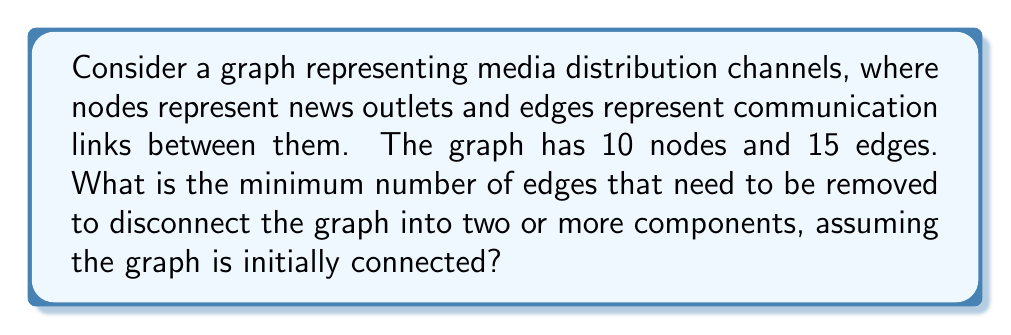Could you help me with this problem? To solve this problem, we need to understand the concept of edge connectivity in graph theory.

1. Edge connectivity is defined as the minimum number of edges that need to be removed to disconnect a graph.

2. For a connected graph with $n$ nodes, the edge connectivity is always less than or equal to the minimum degree of any node in the graph.

3. In this case, we have 10 nodes and 15 edges. Let's calculate the average degree of the nodes:

   Average degree = $\frac{2 \times \text{number of edges}}{\text{number of nodes}} = \frac{2 \times 15}{10} = 3$

4. Since the average degree is 3, the minimum degree of any node in the graph must be less than or equal to 3.

5. The edge connectivity is always less than or equal to the minimum degree. Therefore, the maximum possible edge connectivity for this graph is 3.

6. However, we need to consider that the graph might not be optimally connected. The actual edge connectivity could be 1 (if there's a bridge in the graph) or 2.

7. Without more information about the specific structure of the graph, we can conclude that the minimum number of edges that need to be removed to disconnect the graph is at most 3, but it could be as low as 1.

8. In the context of media distribution channels, this represents the minimum number of communication links that, if severed, would fragment the network of news outlets.
Answer: The minimum number of edges that need to be removed to disconnect the graph is at most 3, but could be as low as 1, depending on the specific structure of the graph. 